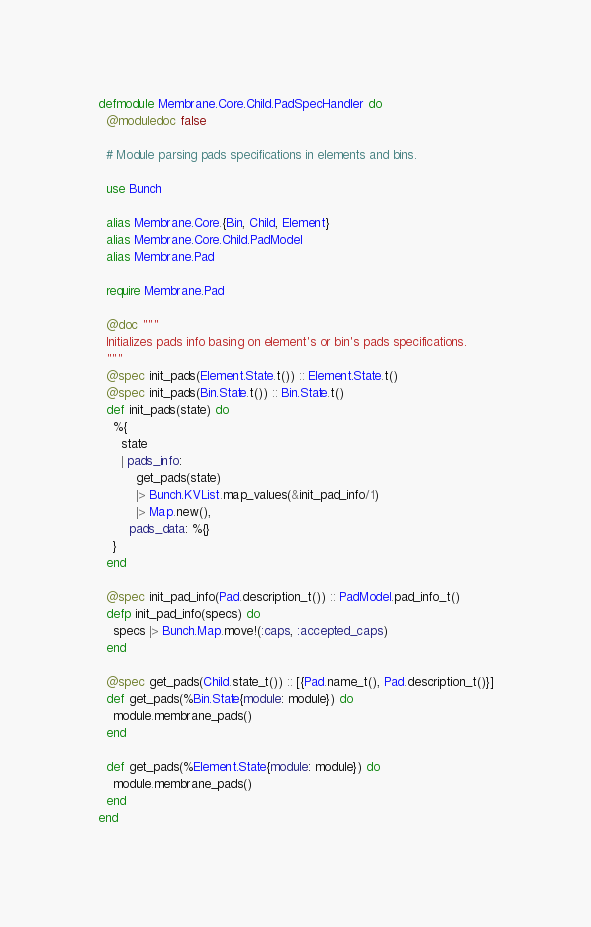Convert code to text. <code><loc_0><loc_0><loc_500><loc_500><_Elixir_>defmodule Membrane.Core.Child.PadSpecHandler do
  @moduledoc false

  # Module parsing pads specifications in elements and bins.

  use Bunch

  alias Membrane.Core.{Bin, Child, Element}
  alias Membrane.Core.Child.PadModel
  alias Membrane.Pad

  require Membrane.Pad

  @doc """
  Initializes pads info basing on element's or bin's pads specifications.
  """
  @spec init_pads(Element.State.t()) :: Element.State.t()
  @spec init_pads(Bin.State.t()) :: Bin.State.t()
  def init_pads(state) do
    %{
      state
      | pads_info:
          get_pads(state)
          |> Bunch.KVList.map_values(&init_pad_info/1)
          |> Map.new(),
        pads_data: %{}
    }
  end

  @spec init_pad_info(Pad.description_t()) :: PadModel.pad_info_t()
  defp init_pad_info(specs) do
    specs |> Bunch.Map.move!(:caps, :accepted_caps)
  end

  @spec get_pads(Child.state_t()) :: [{Pad.name_t(), Pad.description_t()}]
  def get_pads(%Bin.State{module: module}) do
    module.membrane_pads()
  end

  def get_pads(%Element.State{module: module}) do
    module.membrane_pads()
  end
end
</code> 